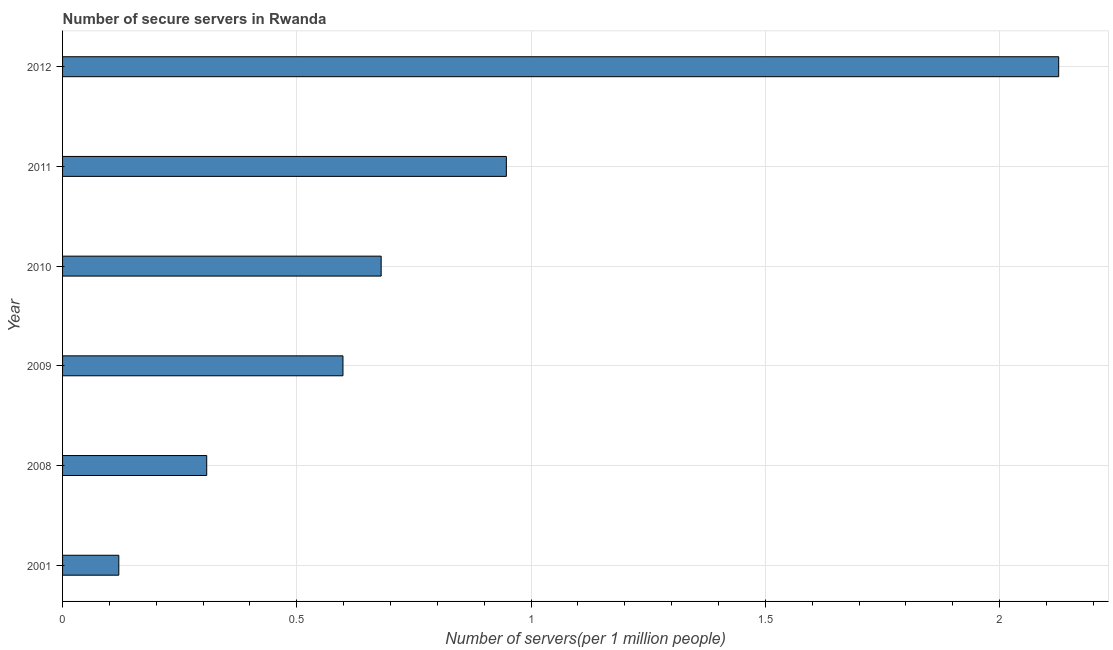Does the graph contain grids?
Keep it short and to the point. Yes. What is the title of the graph?
Your response must be concise. Number of secure servers in Rwanda. What is the label or title of the X-axis?
Offer a very short reply. Number of servers(per 1 million people). What is the number of secure internet servers in 2001?
Make the answer very short. 0.12. Across all years, what is the maximum number of secure internet servers?
Offer a terse response. 2.13. Across all years, what is the minimum number of secure internet servers?
Ensure brevity in your answer.  0.12. What is the sum of the number of secure internet servers?
Keep it short and to the point. 4.78. What is the difference between the number of secure internet servers in 2009 and 2010?
Provide a short and direct response. -0.08. What is the average number of secure internet servers per year?
Keep it short and to the point. 0.8. What is the median number of secure internet servers?
Give a very brief answer. 0.64. In how many years, is the number of secure internet servers greater than 0.3 ?
Ensure brevity in your answer.  5. Do a majority of the years between 2009 and 2011 (inclusive) have number of secure internet servers greater than 2.1 ?
Provide a succinct answer. No. What is the ratio of the number of secure internet servers in 2001 to that in 2008?
Ensure brevity in your answer.  0.39. Is the number of secure internet servers in 2001 less than that in 2009?
Offer a terse response. Yes. What is the difference between the highest and the second highest number of secure internet servers?
Your answer should be compact. 1.18. Is the sum of the number of secure internet servers in 2008 and 2011 greater than the maximum number of secure internet servers across all years?
Provide a short and direct response. No. What is the difference between the highest and the lowest number of secure internet servers?
Provide a short and direct response. 2.01. How many years are there in the graph?
Your answer should be compact. 6. What is the Number of servers(per 1 million people) of 2001?
Make the answer very short. 0.12. What is the Number of servers(per 1 million people) of 2008?
Ensure brevity in your answer.  0.31. What is the Number of servers(per 1 million people) in 2009?
Give a very brief answer. 0.6. What is the Number of servers(per 1 million people) in 2010?
Your answer should be very brief. 0.68. What is the Number of servers(per 1 million people) of 2011?
Your answer should be compact. 0.95. What is the Number of servers(per 1 million people) in 2012?
Keep it short and to the point. 2.13. What is the difference between the Number of servers(per 1 million people) in 2001 and 2008?
Ensure brevity in your answer.  -0.19. What is the difference between the Number of servers(per 1 million people) in 2001 and 2009?
Offer a very short reply. -0.48. What is the difference between the Number of servers(per 1 million people) in 2001 and 2010?
Make the answer very short. -0.56. What is the difference between the Number of servers(per 1 million people) in 2001 and 2011?
Make the answer very short. -0.83. What is the difference between the Number of servers(per 1 million people) in 2001 and 2012?
Provide a short and direct response. -2.01. What is the difference between the Number of servers(per 1 million people) in 2008 and 2009?
Your answer should be compact. -0.29. What is the difference between the Number of servers(per 1 million people) in 2008 and 2010?
Ensure brevity in your answer.  -0.37. What is the difference between the Number of servers(per 1 million people) in 2008 and 2011?
Keep it short and to the point. -0.64. What is the difference between the Number of servers(per 1 million people) in 2008 and 2012?
Your answer should be very brief. -1.82. What is the difference between the Number of servers(per 1 million people) in 2009 and 2010?
Offer a terse response. -0.08. What is the difference between the Number of servers(per 1 million people) in 2009 and 2011?
Your answer should be compact. -0.35. What is the difference between the Number of servers(per 1 million people) in 2009 and 2012?
Give a very brief answer. -1.53. What is the difference between the Number of servers(per 1 million people) in 2010 and 2011?
Offer a terse response. -0.27. What is the difference between the Number of servers(per 1 million people) in 2010 and 2012?
Make the answer very short. -1.45. What is the difference between the Number of servers(per 1 million people) in 2011 and 2012?
Keep it short and to the point. -1.18. What is the ratio of the Number of servers(per 1 million people) in 2001 to that in 2008?
Keep it short and to the point. 0.39. What is the ratio of the Number of servers(per 1 million people) in 2001 to that in 2009?
Offer a terse response. 0.2. What is the ratio of the Number of servers(per 1 million people) in 2001 to that in 2010?
Offer a very short reply. 0.18. What is the ratio of the Number of servers(per 1 million people) in 2001 to that in 2011?
Your response must be concise. 0.13. What is the ratio of the Number of servers(per 1 million people) in 2001 to that in 2012?
Offer a very short reply. 0.06. What is the ratio of the Number of servers(per 1 million people) in 2008 to that in 2009?
Provide a short and direct response. 0.51. What is the ratio of the Number of servers(per 1 million people) in 2008 to that in 2010?
Provide a succinct answer. 0.45. What is the ratio of the Number of servers(per 1 million people) in 2008 to that in 2011?
Your response must be concise. 0.33. What is the ratio of the Number of servers(per 1 million people) in 2008 to that in 2012?
Make the answer very short. 0.14. What is the ratio of the Number of servers(per 1 million people) in 2009 to that in 2010?
Your response must be concise. 0.88. What is the ratio of the Number of servers(per 1 million people) in 2009 to that in 2011?
Offer a very short reply. 0.63. What is the ratio of the Number of servers(per 1 million people) in 2009 to that in 2012?
Your answer should be very brief. 0.28. What is the ratio of the Number of servers(per 1 million people) in 2010 to that in 2011?
Keep it short and to the point. 0.72. What is the ratio of the Number of servers(per 1 million people) in 2010 to that in 2012?
Ensure brevity in your answer.  0.32. What is the ratio of the Number of servers(per 1 million people) in 2011 to that in 2012?
Offer a terse response. 0.45. 